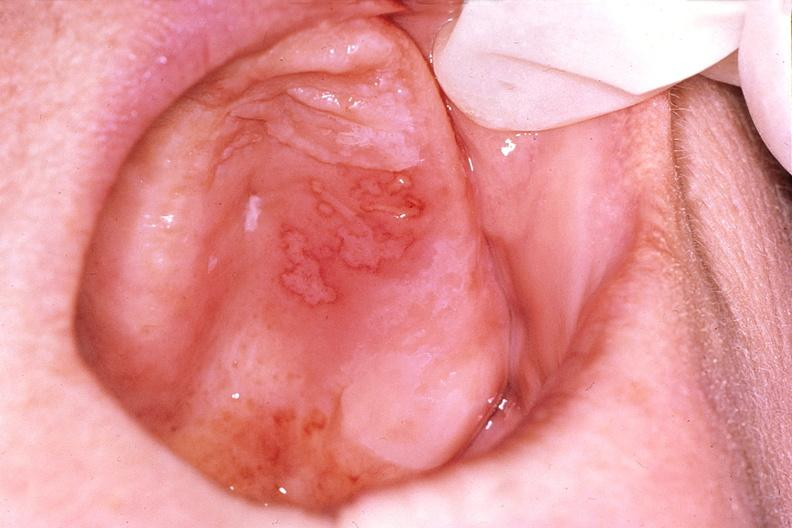s gastrointestinal present?
Answer the question using a single word or phrase. Yes 